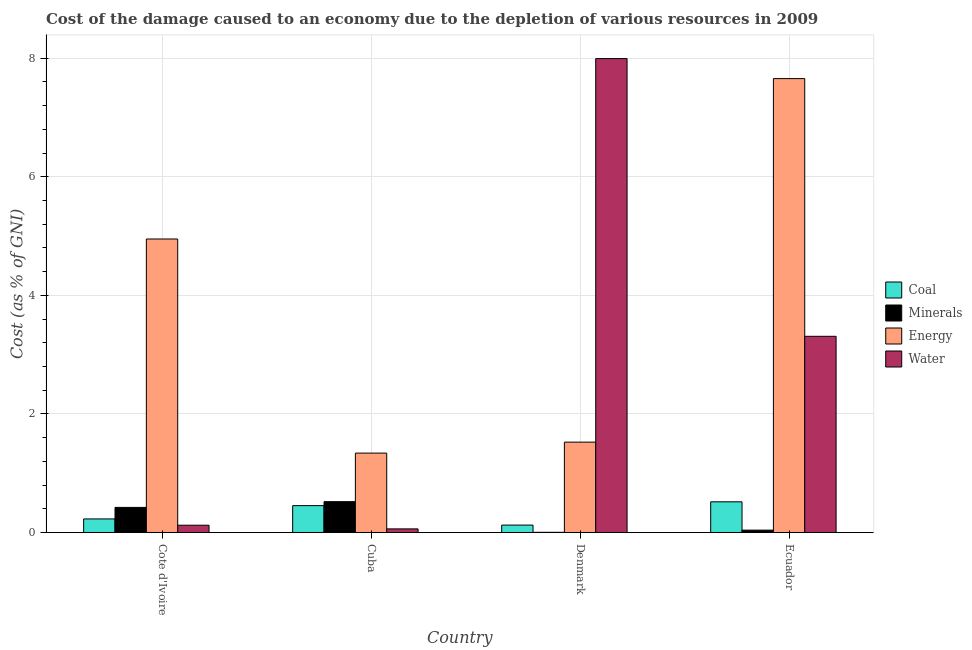What is the label of the 3rd group of bars from the left?
Offer a very short reply. Denmark. In how many cases, is the number of bars for a given country not equal to the number of legend labels?
Make the answer very short. 0. What is the cost of damage due to depletion of water in Cuba?
Give a very brief answer. 0.06. Across all countries, what is the maximum cost of damage due to depletion of coal?
Your response must be concise. 0.52. Across all countries, what is the minimum cost of damage due to depletion of energy?
Offer a very short reply. 1.34. In which country was the cost of damage due to depletion of energy maximum?
Make the answer very short. Ecuador. What is the total cost of damage due to depletion of water in the graph?
Keep it short and to the point. 11.49. What is the difference between the cost of damage due to depletion of water in Denmark and that in Ecuador?
Your response must be concise. 4.68. What is the difference between the cost of damage due to depletion of minerals in Denmark and the cost of damage due to depletion of coal in Ecuador?
Make the answer very short. -0.51. What is the average cost of damage due to depletion of energy per country?
Provide a succinct answer. 3.87. What is the difference between the cost of damage due to depletion of water and cost of damage due to depletion of energy in Cote d'Ivoire?
Provide a short and direct response. -4.83. What is the ratio of the cost of damage due to depletion of minerals in Cote d'Ivoire to that in Denmark?
Keep it short and to the point. 86.05. What is the difference between the highest and the second highest cost of damage due to depletion of energy?
Offer a very short reply. 2.7. What is the difference between the highest and the lowest cost of damage due to depletion of water?
Make the answer very short. 7.93. Is the sum of the cost of damage due to depletion of energy in Cuba and Ecuador greater than the maximum cost of damage due to depletion of coal across all countries?
Provide a succinct answer. Yes. What does the 1st bar from the left in Denmark represents?
Offer a very short reply. Coal. What does the 3rd bar from the right in Cote d'Ivoire represents?
Give a very brief answer. Minerals. How many countries are there in the graph?
Your response must be concise. 4. What is the difference between two consecutive major ticks on the Y-axis?
Provide a succinct answer. 2. Are the values on the major ticks of Y-axis written in scientific E-notation?
Offer a terse response. No. Does the graph contain any zero values?
Give a very brief answer. No. Does the graph contain grids?
Your answer should be very brief. Yes. Where does the legend appear in the graph?
Make the answer very short. Center right. How many legend labels are there?
Provide a succinct answer. 4. How are the legend labels stacked?
Your response must be concise. Vertical. What is the title of the graph?
Provide a short and direct response. Cost of the damage caused to an economy due to the depletion of various resources in 2009 . What is the label or title of the X-axis?
Give a very brief answer. Country. What is the label or title of the Y-axis?
Offer a terse response. Cost (as % of GNI). What is the Cost (as % of GNI) in Coal in Cote d'Ivoire?
Keep it short and to the point. 0.23. What is the Cost (as % of GNI) of Minerals in Cote d'Ivoire?
Your answer should be compact. 0.42. What is the Cost (as % of GNI) of Energy in Cote d'Ivoire?
Make the answer very short. 4.95. What is the Cost (as % of GNI) in Water in Cote d'Ivoire?
Your answer should be very brief. 0.12. What is the Cost (as % of GNI) in Coal in Cuba?
Your answer should be compact. 0.45. What is the Cost (as % of GNI) in Minerals in Cuba?
Your answer should be very brief. 0.52. What is the Cost (as % of GNI) of Energy in Cuba?
Offer a very short reply. 1.34. What is the Cost (as % of GNI) of Water in Cuba?
Provide a succinct answer. 0.06. What is the Cost (as % of GNI) of Coal in Denmark?
Your answer should be compact. 0.13. What is the Cost (as % of GNI) in Minerals in Denmark?
Ensure brevity in your answer.  0. What is the Cost (as % of GNI) of Energy in Denmark?
Provide a short and direct response. 1.53. What is the Cost (as % of GNI) in Water in Denmark?
Keep it short and to the point. 7.99. What is the Cost (as % of GNI) of Coal in Ecuador?
Make the answer very short. 0.52. What is the Cost (as % of GNI) in Minerals in Ecuador?
Your answer should be compact. 0.04. What is the Cost (as % of GNI) of Energy in Ecuador?
Your answer should be very brief. 7.66. What is the Cost (as % of GNI) of Water in Ecuador?
Provide a succinct answer. 3.31. Across all countries, what is the maximum Cost (as % of GNI) in Coal?
Keep it short and to the point. 0.52. Across all countries, what is the maximum Cost (as % of GNI) of Minerals?
Make the answer very short. 0.52. Across all countries, what is the maximum Cost (as % of GNI) in Energy?
Make the answer very short. 7.66. Across all countries, what is the maximum Cost (as % of GNI) in Water?
Your answer should be compact. 7.99. Across all countries, what is the minimum Cost (as % of GNI) of Coal?
Ensure brevity in your answer.  0.13. Across all countries, what is the minimum Cost (as % of GNI) in Minerals?
Your response must be concise. 0. Across all countries, what is the minimum Cost (as % of GNI) in Energy?
Offer a terse response. 1.34. Across all countries, what is the minimum Cost (as % of GNI) of Water?
Keep it short and to the point. 0.06. What is the total Cost (as % of GNI) of Coal in the graph?
Your answer should be compact. 1.33. What is the total Cost (as % of GNI) of Minerals in the graph?
Give a very brief answer. 0.99. What is the total Cost (as % of GNI) in Energy in the graph?
Provide a short and direct response. 15.47. What is the total Cost (as % of GNI) in Water in the graph?
Offer a terse response. 11.49. What is the difference between the Cost (as % of GNI) of Coal in Cote d'Ivoire and that in Cuba?
Offer a very short reply. -0.22. What is the difference between the Cost (as % of GNI) of Minerals in Cote d'Ivoire and that in Cuba?
Make the answer very short. -0.1. What is the difference between the Cost (as % of GNI) in Energy in Cote d'Ivoire and that in Cuba?
Give a very brief answer. 3.61. What is the difference between the Cost (as % of GNI) in Water in Cote d'Ivoire and that in Cuba?
Offer a terse response. 0.06. What is the difference between the Cost (as % of GNI) in Coal in Cote d'Ivoire and that in Denmark?
Make the answer very short. 0.1. What is the difference between the Cost (as % of GNI) of Minerals in Cote d'Ivoire and that in Denmark?
Your answer should be very brief. 0.42. What is the difference between the Cost (as % of GNI) of Energy in Cote d'Ivoire and that in Denmark?
Your answer should be compact. 3.43. What is the difference between the Cost (as % of GNI) of Water in Cote d'Ivoire and that in Denmark?
Ensure brevity in your answer.  -7.87. What is the difference between the Cost (as % of GNI) in Coal in Cote d'Ivoire and that in Ecuador?
Provide a succinct answer. -0.29. What is the difference between the Cost (as % of GNI) in Minerals in Cote d'Ivoire and that in Ecuador?
Provide a short and direct response. 0.38. What is the difference between the Cost (as % of GNI) of Energy in Cote d'Ivoire and that in Ecuador?
Your response must be concise. -2.7. What is the difference between the Cost (as % of GNI) of Water in Cote d'Ivoire and that in Ecuador?
Offer a terse response. -3.19. What is the difference between the Cost (as % of GNI) in Coal in Cuba and that in Denmark?
Ensure brevity in your answer.  0.33. What is the difference between the Cost (as % of GNI) in Minerals in Cuba and that in Denmark?
Provide a succinct answer. 0.52. What is the difference between the Cost (as % of GNI) of Energy in Cuba and that in Denmark?
Provide a succinct answer. -0.18. What is the difference between the Cost (as % of GNI) in Water in Cuba and that in Denmark?
Offer a terse response. -7.93. What is the difference between the Cost (as % of GNI) in Coal in Cuba and that in Ecuador?
Provide a succinct answer. -0.06. What is the difference between the Cost (as % of GNI) in Minerals in Cuba and that in Ecuador?
Ensure brevity in your answer.  0.48. What is the difference between the Cost (as % of GNI) in Energy in Cuba and that in Ecuador?
Make the answer very short. -6.32. What is the difference between the Cost (as % of GNI) of Water in Cuba and that in Ecuador?
Offer a terse response. -3.25. What is the difference between the Cost (as % of GNI) of Coal in Denmark and that in Ecuador?
Offer a terse response. -0.39. What is the difference between the Cost (as % of GNI) of Minerals in Denmark and that in Ecuador?
Make the answer very short. -0.04. What is the difference between the Cost (as % of GNI) of Energy in Denmark and that in Ecuador?
Your response must be concise. -6.13. What is the difference between the Cost (as % of GNI) in Water in Denmark and that in Ecuador?
Provide a succinct answer. 4.68. What is the difference between the Cost (as % of GNI) of Coal in Cote d'Ivoire and the Cost (as % of GNI) of Minerals in Cuba?
Ensure brevity in your answer.  -0.29. What is the difference between the Cost (as % of GNI) in Coal in Cote d'Ivoire and the Cost (as % of GNI) in Energy in Cuba?
Offer a terse response. -1.11. What is the difference between the Cost (as % of GNI) in Coal in Cote d'Ivoire and the Cost (as % of GNI) in Water in Cuba?
Provide a short and direct response. 0.17. What is the difference between the Cost (as % of GNI) of Minerals in Cote d'Ivoire and the Cost (as % of GNI) of Energy in Cuba?
Provide a succinct answer. -0.92. What is the difference between the Cost (as % of GNI) of Minerals in Cote d'Ivoire and the Cost (as % of GNI) of Water in Cuba?
Provide a succinct answer. 0.36. What is the difference between the Cost (as % of GNI) in Energy in Cote d'Ivoire and the Cost (as % of GNI) in Water in Cuba?
Offer a terse response. 4.89. What is the difference between the Cost (as % of GNI) of Coal in Cote d'Ivoire and the Cost (as % of GNI) of Minerals in Denmark?
Provide a short and direct response. 0.23. What is the difference between the Cost (as % of GNI) of Coal in Cote d'Ivoire and the Cost (as % of GNI) of Energy in Denmark?
Your answer should be compact. -1.29. What is the difference between the Cost (as % of GNI) of Coal in Cote d'Ivoire and the Cost (as % of GNI) of Water in Denmark?
Offer a very short reply. -7.76. What is the difference between the Cost (as % of GNI) of Minerals in Cote d'Ivoire and the Cost (as % of GNI) of Energy in Denmark?
Provide a short and direct response. -1.1. What is the difference between the Cost (as % of GNI) in Minerals in Cote d'Ivoire and the Cost (as % of GNI) in Water in Denmark?
Make the answer very short. -7.57. What is the difference between the Cost (as % of GNI) in Energy in Cote d'Ivoire and the Cost (as % of GNI) in Water in Denmark?
Provide a succinct answer. -3.04. What is the difference between the Cost (as % of GNI) in Coal in Cote d'Ivoire and the Cost (as % of GNI) in Minerals in Ecuador?
Offer a very short reply. 0.19. What is the difference between the Cost (as % of GNI) in Coal in Cote d'Ivoire and the Cost (as % of GNI) in Energy in Ecuador?
Your answer should be very brief. -7.43. What is the difference between the Cost (as % of GNI) of Coal in Cote d'Ivoire and the Cost (as % of GNI) of Water in Ecuador?
Ensure brevity in your answer.  -3.08. What is the difference between the Cost (as % of GNI) of Minerals in Cote d'Ivoire and the Cost (as % of GNI) of Energy in Ecuador?
Your response must be concise. -7.23. What is the difference between the Cost (as % of GNI) in Minerals in Cote d'Ivoire and the Cost (as % of GNI) in Water in Ecuador?
Your answer should be compact. -2.89. What is the difference between the Cost (as % of GNI) of Energy in Cote d'Ivoire and the Cost (as % of GNI) of Water in Ecuador?
Provide a short and direct response. 1.64. What is the difference between the Cost (as % of GNI) in Coal in Cuba and the Cost (as % of GNI) in Minerals in Denmark?
Give a very brief answer. 0.45. What is the difference between the Cost (as % of GNI) in Coal in Cuba and the Cost (as % of GNI) in Energy in Denmark?
Provide a succinct answer. -1.07. What is the difference between the Cost (as % of GNI) of Coal in Cuba and the Cost (as % of GNI) of Water in Denmark?
Make the answer very short. -7.54. What is the difference between the Cost (as % of GNI) of Minerals in Cuba and the Cost (as % of GNI) of Energy in Denmark?
Provide a succinct answer. -1. What is the difference between the Cost (as % of GNI) in Minerals in Cuba and the Cost (as % of GNI) in Water in Denmark?
Make the answer very short. -7.47. What is the difference between the Cost (as % of GNI) in Energy in Cuba and the Cost (as % of GNI) in Water in Denmark?
Ensure brevity in your answer.  -6.65. What is the difference between the Cost (as % of GNI) in Coal in Cuba and the Cost (as % of GNI) in Minerals in Ecuador?
Your answer should be very brief. 0.41. What is the difference between the Cost (as % of GNI) in Coal in Cuba and the Cost (as % of GNI) in Energy in Ecuador?
Provide a succinct answer. -7.2. What is the difference between the Cost (as % of GNI) in Coal in Cuba and the Cost (as % of GNI) in Water in Ecuador?
Ensure brevity in your answer.  -2.86. What is the difference between the Cost (as % of GNI) of Minerals in Cuba and the Cost (as % of GNI) of Energy in Ecuador?
Your answer should be very brief. -7.13. What is the difference between the Cost (as % of GNI) in Minerals in Cuba and the Cost (as % of GNI) in Water in Ecuador?
Provide a succinct answer. -2.79. What is the difference between the Cost (as % of GNI) in Energy in Cuba and the Cost (as % of GNI) in Water in Ecuador?
Ensure brevity in your answer.  -1.97. What is the difference between the Cost (as % of GNI) in Coal in Denmark and the Cost (as % of GNI) in Minerals in Ecuador?
Ensure brevity in your answer.  0.09. What is the difference between the Cost (as % of GNI) in Coal in Denmark and the Cost (as % of GNI) in Energy in Ecuador?
Ensure brevity in your answer.  -7.53. What is the difference between the Cost (as % of GNI) in Coal in Denmark and the Cost (as % of GNI) in Water in Ecuador?
Keep it short and to the point. -3.18. What is the difference between the Cost (as % of GNI) in Minerals in Denmark and the Cost (as % of GNI) in Energy in Ecuador?
Offer a very short reply. -7.65. What is the difference between the Cost (as % of GNI) of Minerals in Denmark and the Cost (as % of GNI) of Water in Ecuador?
Your answer should be very brief. -3.31. What is the difference between the Cost (as % of GNI) of Energy in Denmark and the Cost (as % of GNI) of Water in Ecuador?
Offer a very short reply. -1.78. What is the average Cost (as % of GNI) in Coal per country?
Keep it short and to the point. 0.33. What is the average Cost (as % of GNI) in Minerals per country?
Offer a very short reply. 0.25. What is the average Cost (as % of GNI) of Energy per country?
Make the answer very short. 3.87. What is the average Cost (as % of GNI) of Water per country?
Ensure brevity in your answer.  2.87. What is the difference between the Cost (as % of GNI) in Coal and Cost (as % of GNI) in Minerals in Cote d'Ivoire?
Your answer should be very brief. -0.19. What is the difference between the Cost (as % of GNI) of Coal and Cost (as % of GNI) of Energy in Cote d'Ivoire?
Offer a terse response. -4.72. What is the difference between the Cost (as % of GNI) in Coal and Cost (as % of GNI) in Water in Cote d'Ivoire?
Provide a succinct answer. 0.11. What is the difference between the Cost (as % of GNI) of Minerals and Cost (as % of GNI) of Energy in Cote d'Ivoire?
Give a very brief answer. -4.53. What is the difference between the Cost (as % of GNI) of Minerals and Cost (as % of GNI) of Water in Cote d'Ivoire?
Your answer should be compact. 0.3. What is the difference between the Cost (as % of GNI) of Energy and Cost (as % of GNI) of Water in Cote d'Ivoire?
Offer a very short reply. 4.83. What is the difference between the Cost (as % of GNI) of Coal and Cost (as % of GNI) of Minerals in Cuba?
Make the answer very short. -0.07. What is the difference between the Cost (as % of GNI) of Coal and Cost (as % of GNI) of Energy in Cuba?
Offer a terse response. -0.89. What is the difference between the Cost (as % of GNI) in Coal and Cost (as % of GNI) in Water in Cuba?
Ensure brevity in your answer.  0.39. What is the difference between the Cost (as % of GNI) in Minerals and Cost (as % of GNI) in Energy in Cuba?
Offer a very short reply. -0.82. What is the difference between the Cost (as % of GNI) in Minerals and Cost (as % of GNI) in Water in Cuba?
Your response must be concise. 0.46. What is the difference between the Cost (as % of GNI) in Energy and Cost (as % of GNI) in Water in Cuba?
Provide a short and direct response. 1.28. What is the difference between the Cost (as % of GNI) of Coal and Cost (as % of GNI) of Minerals in Denmark?
Offer a very short reply. 0.12. What is the difference between the Cost (as % of GNI) of Coal and Cost (as % of GNI) of Energy in Denmark?
Offer a terse response. -1.4. What is the difference between the Cost (as % of GNI) in Coal and Cost (as % of GNI) in Water in Denmark?
Provide a short and direct response. -7.87. What is the difference between the Cost (as % of GNI) in Minerals and Cost (as % of GNI) in Energy in Denmark?
Ensure brevity in your answer.  -1.52. What is the difference between the Cost (as % of GNI) in Minerals and Cost (as % of GNI) in Water in Denmark?
Provide a succinct answer. -7.99. What is the difference between the Cost (as % of GNI) of Energy and Cost (as % of GNI) of Water in Denmark?
Your response must be concise. -6.47. What is the difference between the Cost (as % of GNI) in Coal and Cost (as % of GNI) in Minerals in Ecuador?
Provide a succinct answer. 0.48. What is the difference between the Cost (as % of GNI) in Coal and Cost (as % of GNI) in Energy in Ecuador?
Offer a very short reply. -7.14. What is the difference between the Cost (as % of GNI) in Coal and Cost (as % of GNI) in Water in Ecuador?
Offer a terse response. -2.79. What is the difference between the Cost (as % of GNI) of Minerals and Cost (as % of GNI) of Energy in Ecuador?
Offer a terse response. -7.61. What is the difference between the Cost (as % of GNI) in Minerals and Cost (as % of GNI) in Water in Ecuador?
Keep it short and to the point. -3.27. What is the difference between the Cost (as % of GNI) of Energy and Cost (as % of GNI) of Water in Ecuador?
Keep it short and to the point. 4.35. What is the ratio of the Cost (as % of GNI) in Coal in Cote d'Ivoire to that in Cuba?
Provide a short and direct response. 0.51. What is the ratio of the Cost (as % of GNI) in Minerals in Cote d'Ivoire to that in Cuba?
Your response must be concise. 0.81. What is the ratio of the Cost (as % of GNI) in Energy in Cote d'Ivoire to that in Cuba?
Provide a short and direct response. 3.69. What is the ratio of the Cost (as % of GNI) of Water in Cote d'Ivoire to that in Cuba?
Offer a very short reply. 1.99. What is the ratio of the Cost (as % of GNI) in Coal in Cote d'Ivoire to that in Denmark?
Your response must be concise. 1.82. What is the ratio of the Cost (as % of GNI) in Minerals in Cote d'Ivoire to that in Denmark?
Keep it short and to the point. 86.05. What is the ratio of the Cost (as % of GNI) in Energy in Cote d'Ivoire to that in Denmark?
Make the answer very short. 3.25. What is the ratio of the Cost (as % of GNI) in Water in Cote d'Ivoire to that in Denmark?
Your answer should be very brief. 0.02. What is the ratio of the Cost (as % of GNI) of Coal in Cote d'Ivoire to that in Ecuador?
Give a very brief answer. 0.44. What is the ratio of the Cost (as % of GNI) of Minerals in Cote d'Ivoire to that in Ecuador?
Provide a short and direct response. 10.27. What is the ratio of the Cost (as % of GNI) of Energy in Cote d'Ivoire to that in Ecuador?
Keep it short and to the point. 0.65. What is the ratio of the Cost (as % of GNI) in Water in Cote d'Ivoire to that in Ecuador?
Give a very brief answer. 0.04. What is the ratio of the Cost (as % of GNI) of Coal in Cuba to that in Denmark?
Your answer should be very brief. 3.59. What is the ratio of the Cost (as % of GNI) of Minerals in Cuba to that in Denmark?
Give a very brief answer. 105.67. What is the ratio of the Cost (as % of GNI) of Energy in Cuba to that in Denmark?
Provide a short and direct response. 0.88. What is the ratio of the Cost (as % of GNI) in Water in Cuba to that in Denmark?
Keep it short and to the point. 0.01. What is the ratio of the Cost (as % of GNI) in Coal in Cuba to that in Ecuador?
Keep it short and to the point. 0.88. What is the ratio of the Cost (as % of GNI) in Minerals in Cuba to that in Ecuador?
Keep it short and to the point. 12.62. What is the ratio of the Cost (as % of GNI) in Energy in Cuba to that in Ecuador?
Ensure brevity in your answer.  0.18. What is the ratio of the Cost (as % of GNI) of Water in Cuba to that in Ecuador?
Your answer should be very brief. 0.02. What is the ratio of the Cost (as % of GNI) of Coal in Denmark to that in Ecuador?
Make the answer very short. 0.24. What is the ratio of the Cost (as % of GNI) of Minerals in Denmark to that in Ecuador?
Your answer should be very brief. 0.12. What is the ratio of the Cost (as % of GNI) of Energy in Denmark to that in Ecuador?
Give a very brief answer. 0.2. What is the ratio of the Cost (as % of GNI) of Water in Denmark to that in Ecuador?
Your answer should be very brief. 2.42. What is the difference between the highest and the second highest Cost (as % of GNI) in Coal?
Provide a succinct answer. 0.06. What is the difference between the highest and the second highest Cost (as % of GNI) of Minerals?
Keep it short and to the point. 0.1. What is the difference between the highest and the second highest Cost (as % of GNI) of Energy?
Offer a very short reply. 2.7. What is the difference between the highest and the second highest Cost (as % of GNI) of Water?
Offer a terse response. 4.68. What is the difference between the highest and the lowest Cost (as % of GNI) of Coal?
Your answer should be compact. 0.39. What is the difference between the highest and the lowest Cost (as % of GNI) of Minerals?
Your response must be concise. 0.52. What is the difference between the highest and the lowest Cost (as % of GNI) in Energy?
Ensure brevity in your answer.  6.32. What is the difference between the highest and the lowest Cost (as % of GNI) of Water?
Keep it short and to the point. 7.93. 